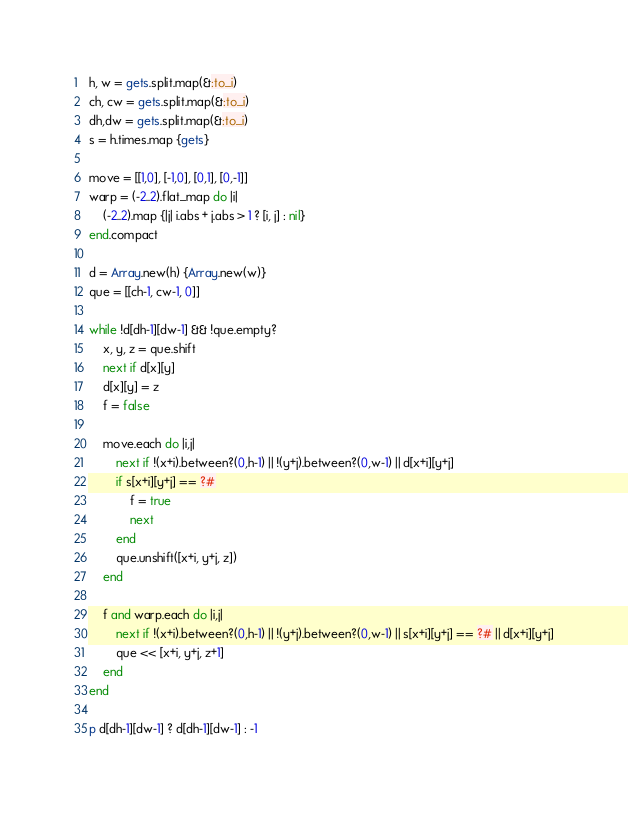<code> <loc_0><loc_0><loc_500><loc_500><_Ruby_>h, w = gets.split.map(&:to_i)
ch, cw = gets.split.map(&:to_i)
dh,dw = gets.split.map(&:to_i)
s = h.times.map {gets}

move = [[1,0], [-1,0], [0,1], [0,-1]]
warp = (-2..2).flat_map do |i|
    (-2..2).map {|j| i.abs + j.abs > 1 ? [i, j] : nil}
end.compact

d = Array.new(h) {Array.new(w)}
que = [[ch-1, cw-1, 0]]

while !d[dh-1][dw-1] && !que.empty?
    x, y, z = que.shift
    next if d[x][y]
    d[x][y] = z
    f = false
    
    move.each do |i,j|
        next if !(x+i).between?(0,h-1) || !(y+j).between?(0,w-1) || d[x+i][y+j]
        if s[x+i][y+j] == ?#
            f = true
            next
        end
        que.unshift([x+i, y+j, z])
    end

    f and warp.each do |i,j|
        next if !(x+i).between?(0,h-1) || !(y+j).between?(0,w-1) || s[x+i][y+j] == ?# || d[x+i][y+j]
        que << [x+i, y+j, z+1]
    end
end

p d[dh-1][dw-1] ? d[dh-1][dw-1] : -1</code> 